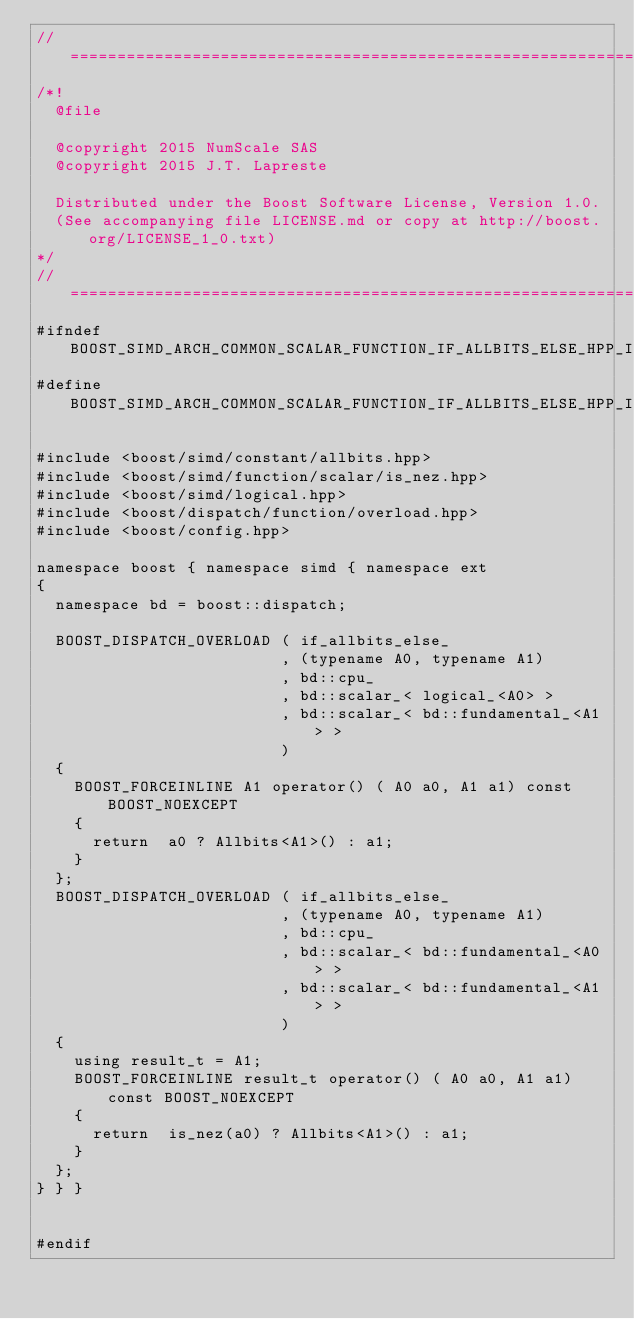<code> <loc_0><loc_0><loc_500><loc_500><_C++_>//==================================================================================================
/*!
  @file

  @copyright 2015 NumScale SAS
  @copyright 2015 J.T. Lapreste

  Distributed under the Boost Software License, Version 1.0.
  (See accompanying file LICENSE.md or copy at http://boost.org/LICENSE_1_0.txt)
*/
//==================================================================================================
#ifndef BOOST_SIMD_ARCH_COMMON_SCALAR_FUNCTION_IF_ALLBITS_ELSE_HPP_INCLUDED
#define BOOST_SIMD_ARCH_COMMON_SCALAR_FUNCTION_IF_ALLBITS_ELSE_HPP_INCLUDED

#include <boost/simd/constant/allbits.hpp>
#include <boost/simd/function/scalar/is_nez.hpp>
#include <boost/simd/logical.hpp>
#include <boost/dispatch/function/overload.hpp>
#include <boost/config.hpp>

namespace boost { namespace simd { namespace ext
{
  namespace bd = boost::dispatch;

  BOOST_DISPATCH_OVERLOAD ( if_allbits_else_
                          , (typename A0, typename A1)
                          , bd::cpu_
                          , bd::scalar_< logical_<A0> >
                          , bd::scalar_< bd::fundamental_<A1> >
                          )
  {
    BOOST_FORCEINLINE A1 operator() ( A0 a0, A1 a1) const BOOST_NOEXCEPT
    {
      return  a0 ? Allbits<A1>() : a1;
    }
  };
  BOOST_DISPATCH_OVERLOAD ( if_allbits_else_
                          , (typename A0, typename A1)
                          , bd::cpu_
                          , bd::scalar_< bd::fundamental_<A0> >
                          , bd::scalar_< bd::fundamental_<A1> >
                          )
  {
    using result_t = A1;
    BOOST_FORCEINLINE result_t operator() ( A0 a0, A1 a1) const BOOST_NOEXCEPT
    {
      return  is_nez(a0) ? Allbits<A1>() : a1;
    }
  };
} } }


#endif
</code> 